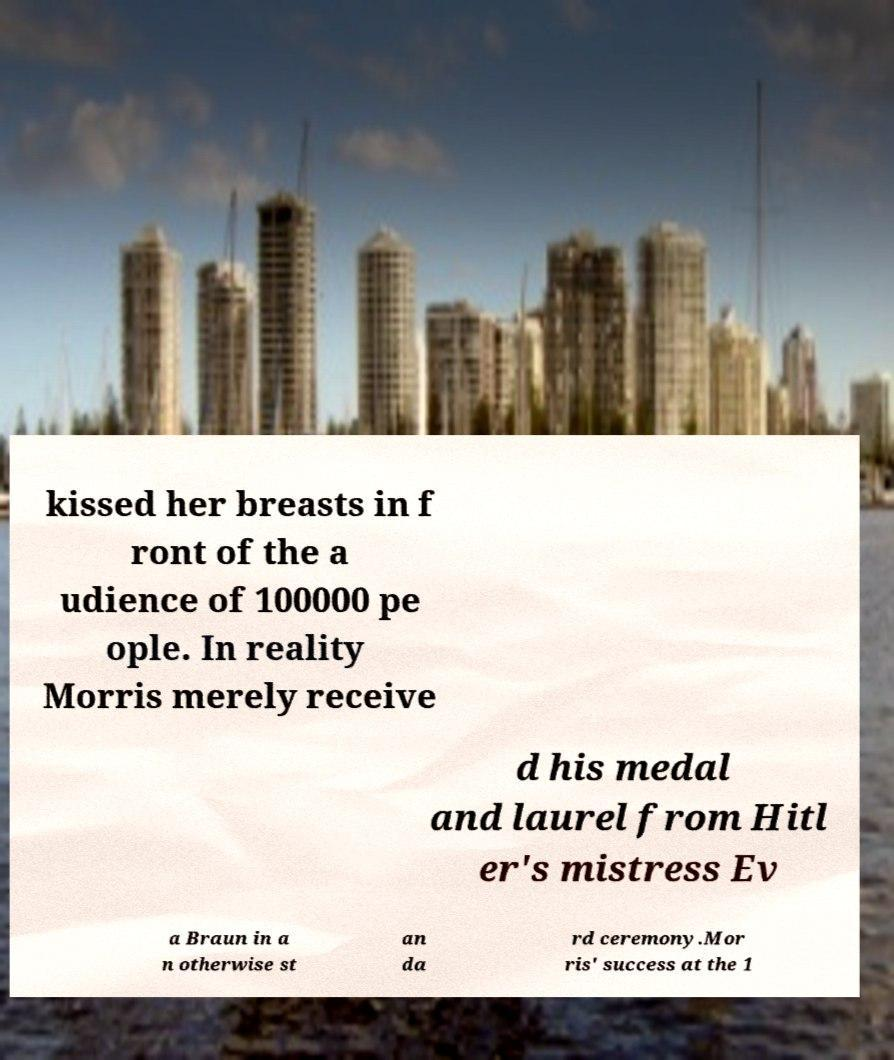Could you assist in decoding the text presented in this image and type it out clearly? kissed her breasts in f ront of the a udience of 100000 pe ople. In reality Morris merely receive d his medal and laurel from Hitl er's mistress Ev a Braun in a n otherwise st an da rd ceremony.Mor ris' success at the 1 